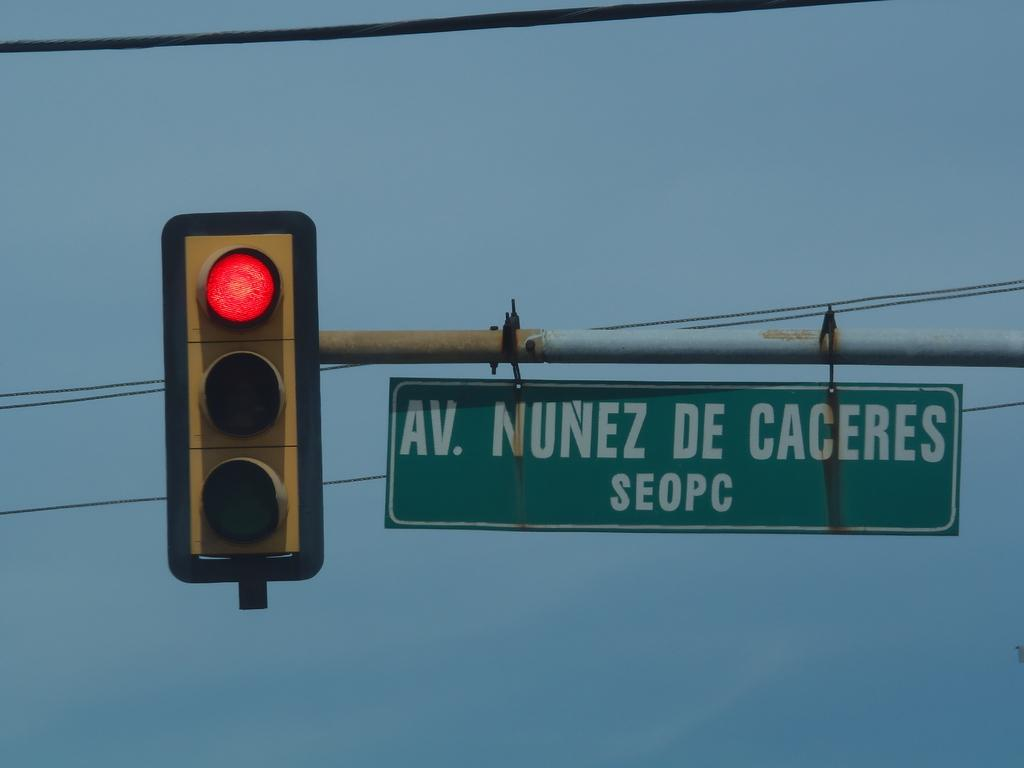<image>
Render a clear and concise summary of the photo. A street sign for Nunez de Caceres is hanging next to a red traffic light. 